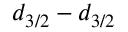<formula> <loc_0><loc_0><loc_500><loc_500>d _ { 3 / 2 } - d _ { 3 / 2 }</formula> 